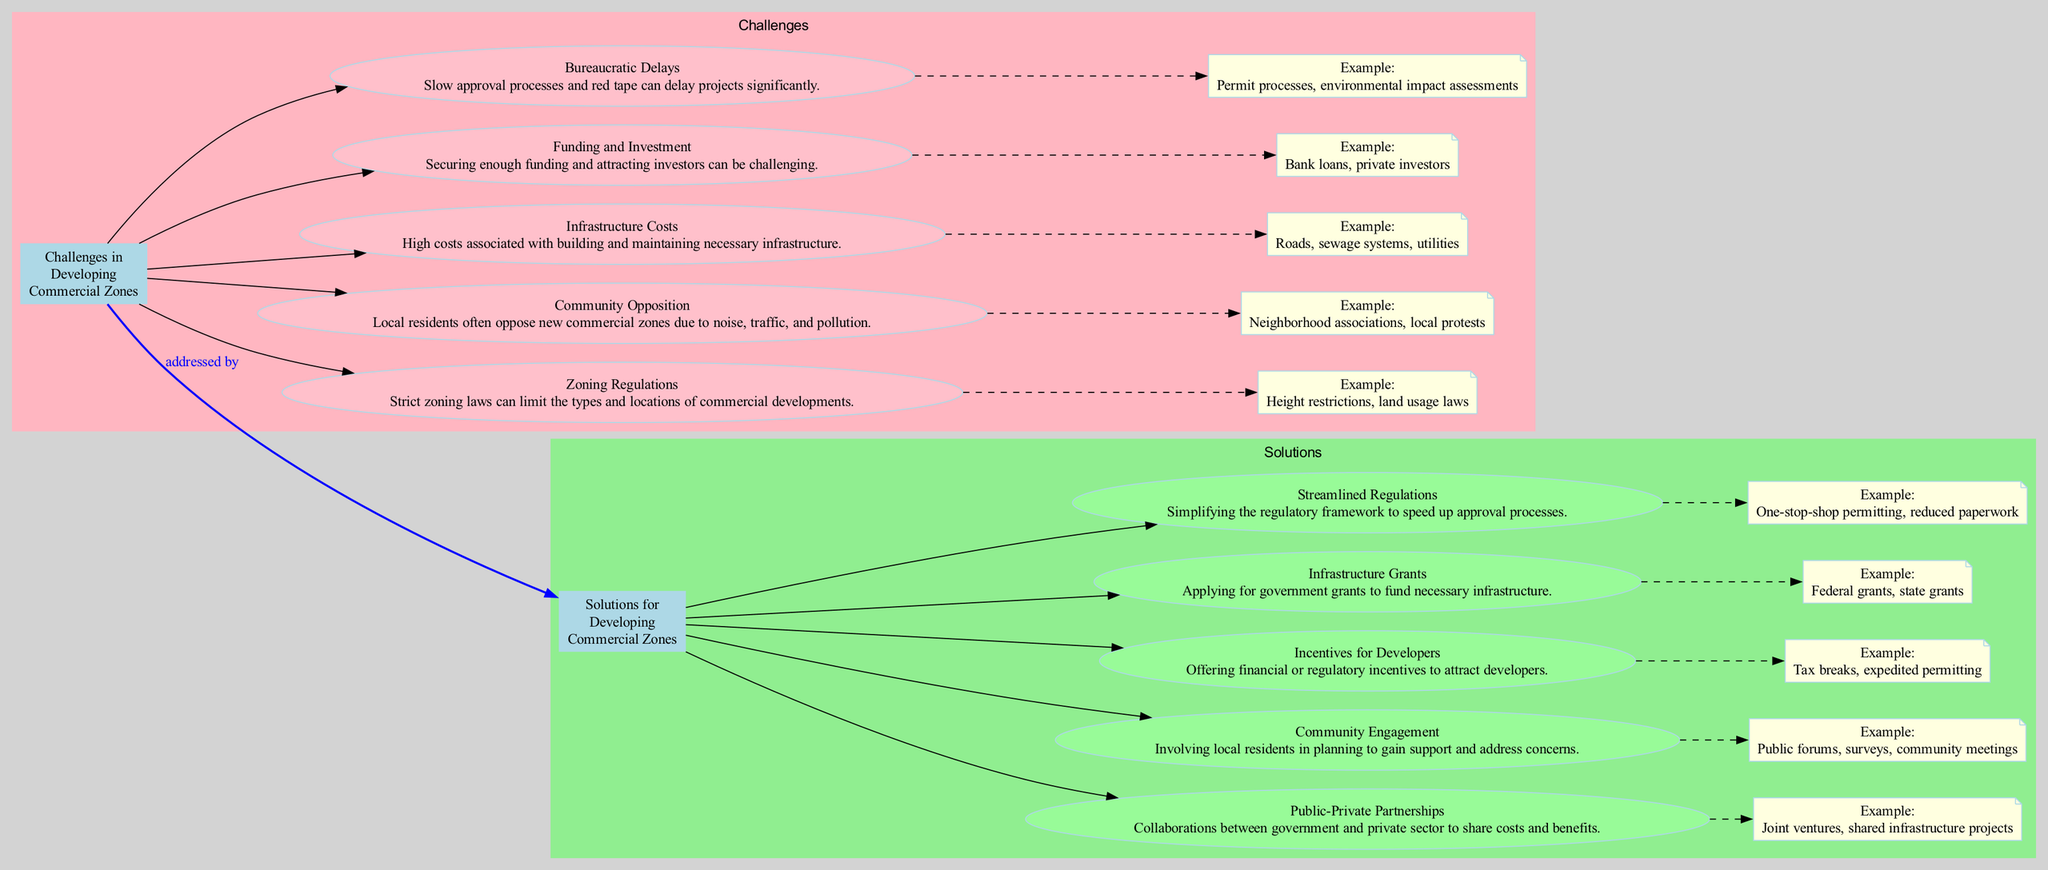What are the main categories in the diagram? The main categories in the diagram are "Challenges in Developing Commercial Zones" and "Solutions for Developing Commercial Zones." These categories are visually connected to show a distinction between the problems and potential solutions.
Answer: Challenges and Solutions How many challenges are listed in the diagram? There are five challenges listed in the diagram: Zoning Regulations, Community Opposition, Infrastructure Costs, Funding and Investment, and Bureaucratic Delays. Each challenge is represented as a separate node.
Answer: Five What are the examples provided for Community Opposition? The example provided for Community Opposition is "Neighborhood associations, local protests." This information is included under the Community Opposition node as a noted detail related to the challenge.
Answer: Neighborhood associations, local protests Which solution specifically addresses community concerns? The solution that specifically addresses community concerns is "Community Engagement." This solution involves local residents in planning, which is aimed at gaining support and addressing their concerns.
Answer: Community Engagement What type of relationship exists between challenges and solutions? The relationship between challenges and solutions is labeled as "addressed by". This indicates that the solutions are intended to tackle or resolve the listed challenges, creating an actionable link between the two categories.
Answer: Addressed by What is the description of the "Incentives for Developers" solution? The description of the "Incentives for Developers" solution is "Offering financial or regulatory incentives to attract developers." This brief explanation highlights the purpose and nature of the solution provided in the diagram.
Answer: Offering financial or regulatory incentives to attract developers How does "Infrastructure Grants" assist in developing commercial zones? "Infrastructure Grants" assists in developing commercial zones by providing funding through government grants for necessary infrastructure. This information elaborates on one of the solutions available to handle infrastructure costs.
Answer: Funding through government grants for necessary infrastructure What type of engagement method is mentioned under Community Engagement? The engagement methods mentioned under Community Engagement include "Public forums, surveys, community meetings." These methods are designed to get feedback from local residents and involve them in the planning process.
Answer: Public forums, surveys, community meetings 